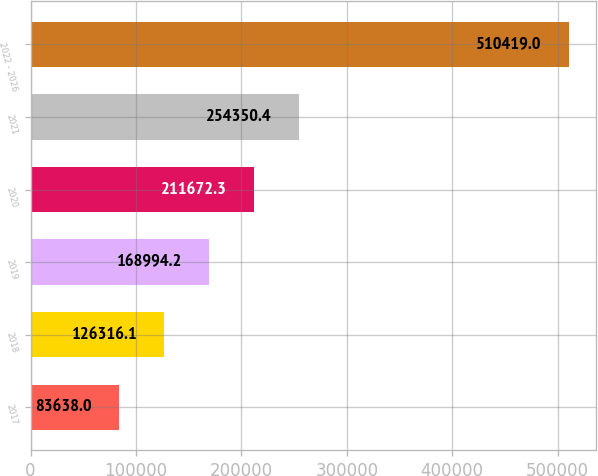Convert chart. <chart><loc_0><loc_0><loc_500><loc_500><bar_chart><fcel>2017<fcel>2018<fcel>2019<fcel>2020<fcel>2021<fcel>2022 - 2026<nl><fcel>83638<fcel>126316<fcel>168994<fcel>211672<fcel>254350<fcel>510419<nl></chart> 